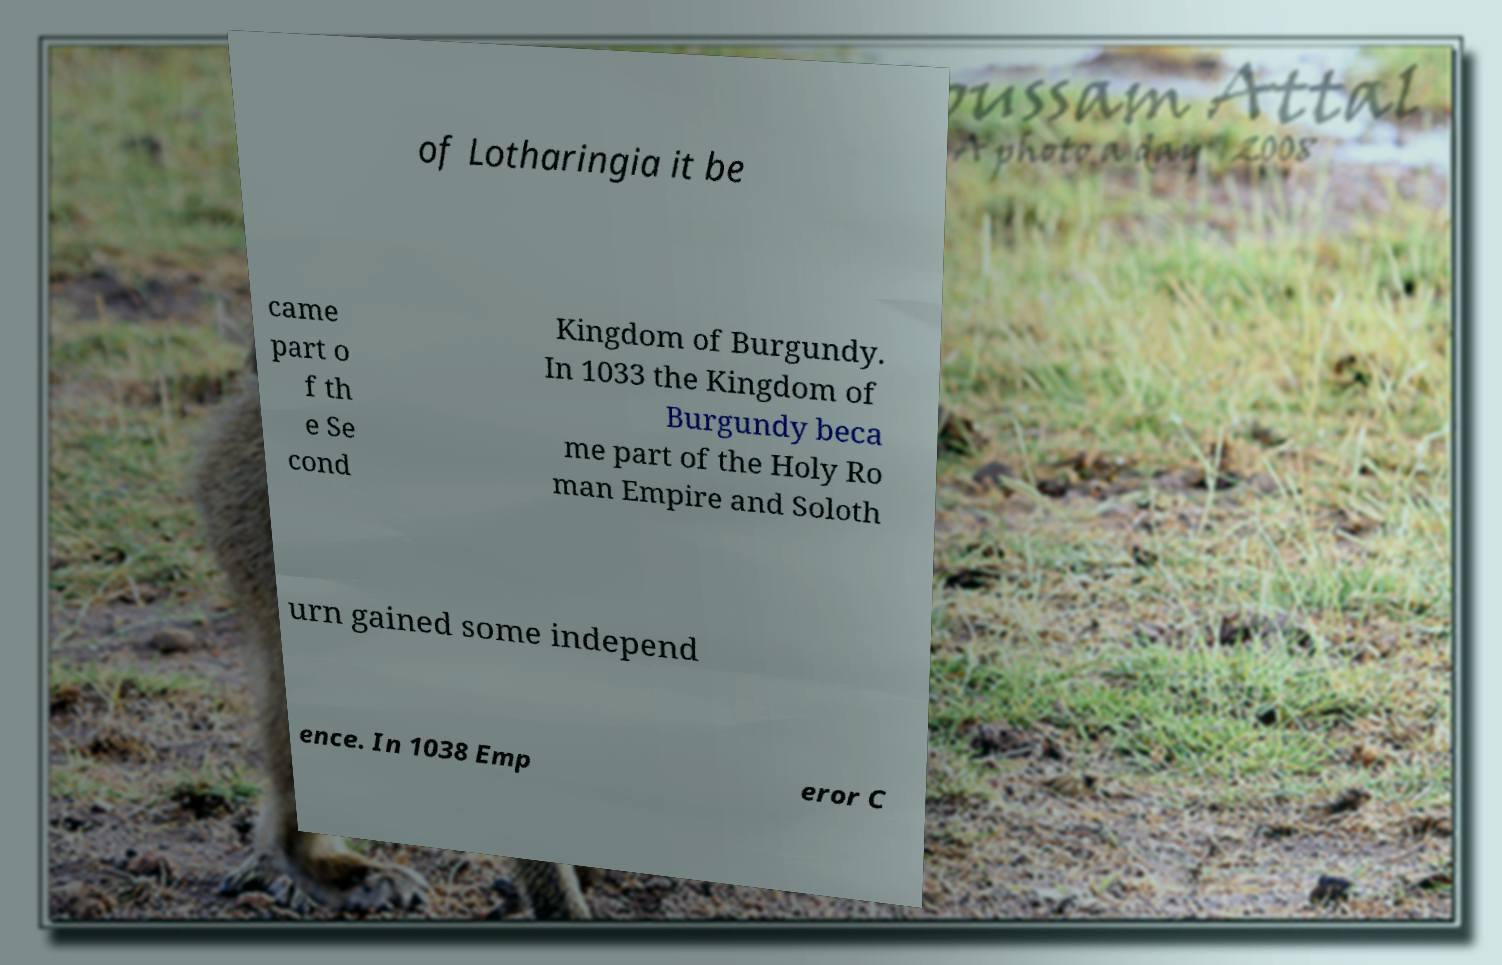There's text embedded in this image that I need extracted. Can you transcribe it verbatim? of Lotharingia it be came part o f th e Se cond Kingdom of Burgundy. In 1033 the Kingdom of Burgundy beca me part of the Holy Ro man Empire and Soloth urn gained some independ ence. In 1038 Emp eror C 